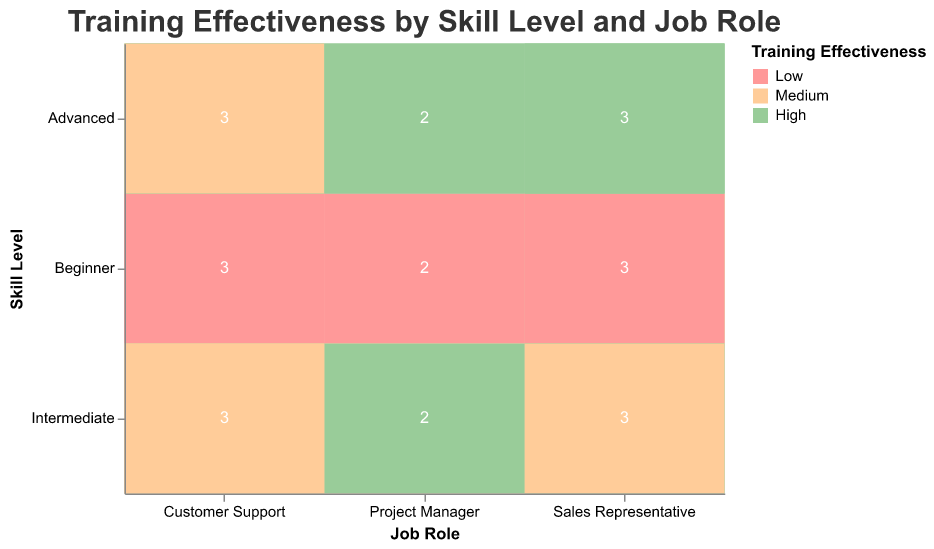What is the title of the figure? The title is usually displayed at the top of the chart in a larger font size, and it summarizes the content of the chart. In this case, the title is "Training Effectiveness by Skill Level and Job Role".
Answer: Training Effectiveness by Skill Level and Job Role Which job role has a higher count of high training effectiveness for Intermediate skill level, Sales Representative or Customer Support? We need to compare the number of "High" effectiveness blocks for "Intermediate" skill level between "Sales Representative" and "Customer Support". For "Intermediate" skill level, "Sales Representative" has 2 high effectiveness blocks, whereas "Customer Support" has 1.
Answer: Sales Representative How many instances of "Low" training effectiveness are there for Project Managers at all skill levels? We count the number of "Low" effectiveness occurrences for "Project Manager" role considering all skill levels (Beginner, Intermediate, Advanced). There are 2 in Beginner, and none in Intermediate and Advanced levels.
Answer: 2 Which skill level has the highest number of high training effectiveness in the Customer Support role? We need to check the counts of "High" effectiveness for each skill level within the "Customer Support" job role. The "Advanced" skill level has the highest with 2 occurrences.
Answer: Advanced What's the count of medium training effectiveness for Sales Representatives and Customer Support combined? Count the "Medium" effectiveness blocks for "Sales Representative" and "Customer Support". For Sales Representative, it's 1; for Customer Support, it's 3. Summing these gives 1 + 3 = 4.
Answer: 4 